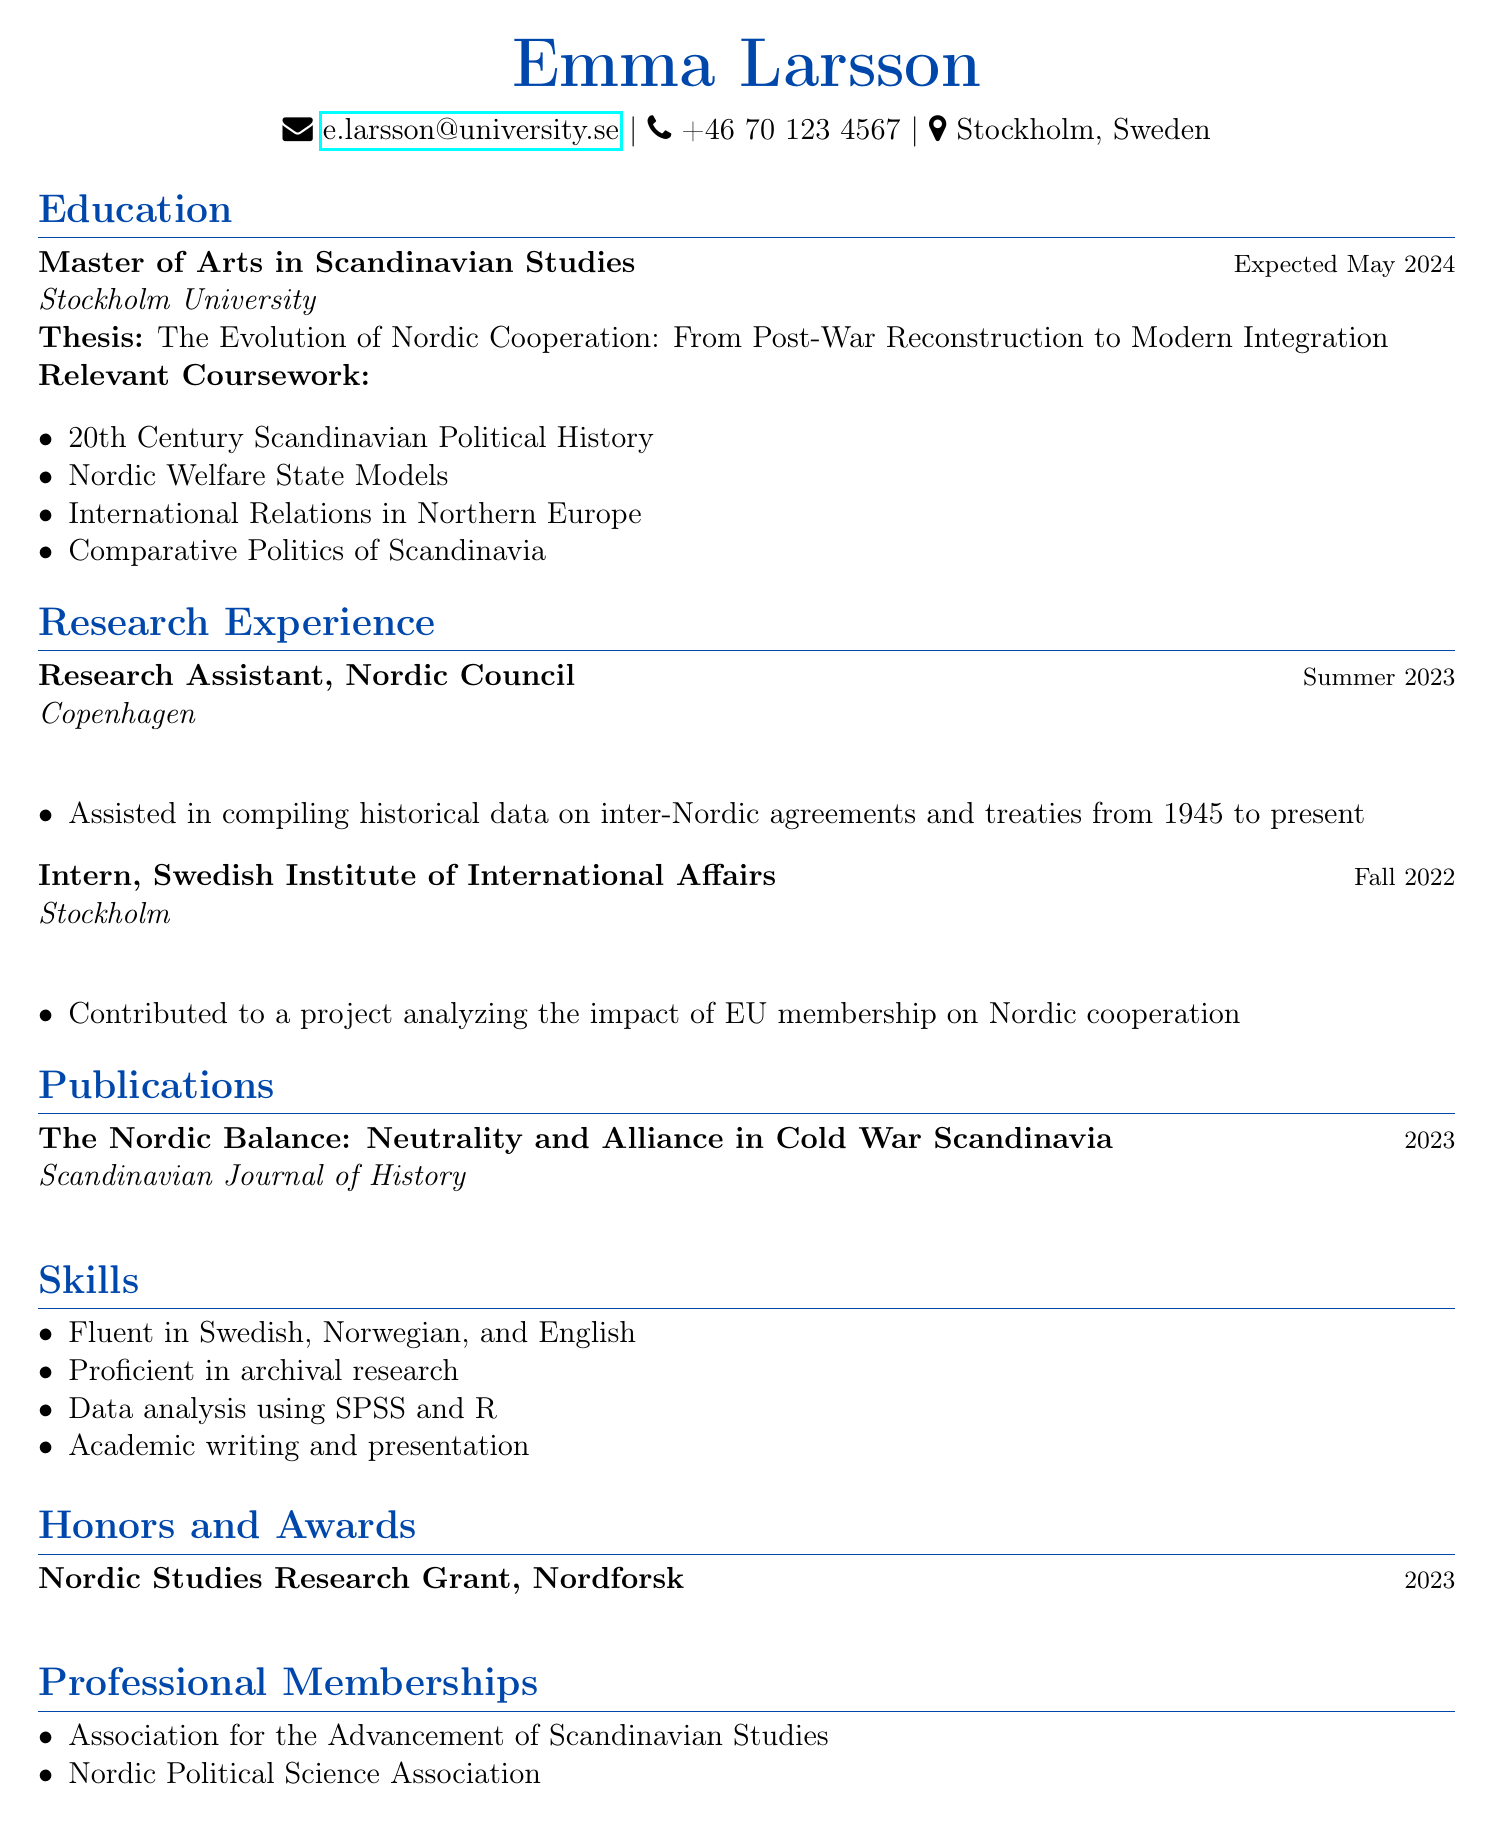What is Emma Larsson's email address? The email address is listed in the personal information section as a means of contact.
Answer: e.larsson@university.se When is Emma expected to graduate? The expected graduation date is noted in the education section of the resume.
Answer: May 2024 What is the title of Emma's thesis? The thesis title is specified in the education section, highlighting the focus of her research.
Answer: The Evolution of Nordic Cooperation: From Post-War Reconstruction to Modern Integration How many relevant coursework subjects are listed? The relevant coursework section details several courses related to Emma's studies, indicating the breadth of her education.
Answer: 4 What position did Emma hold at the Nordic Council? The resume lists her position at the Nordic Council under research experience.
Answer: Research Assistant Which journal published Emma's recent article? The publication section notes where her work was published, an important aspect for academic credentials.
Answer: Scandinavian Journal of History What award did Emma receive in 2023? The honors and awards section highlights significant achievements, showcasing her recognition in her field.
Answer: Nordic Studies Research Grant How many languages is Emma fluent in? The skills section specifies her language abilities, which is relevant to her research capabilities.
Answer: 3 Which professional memberships does Emma hold? The professional memberships section lists organizations she is part of, indicating her engagement in her field.
Answer: Association for the Advancement of Scandinavian Studies, Nordic Political Science Association 